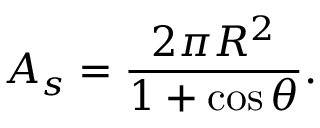Convert formula to latex. <formula><loc_0><loc_0><loc_500><loc_500>A _ { s } = { \frac { 2 \pi R ^ { 2 } } { 1 + \cos \theta } } .</formula> 